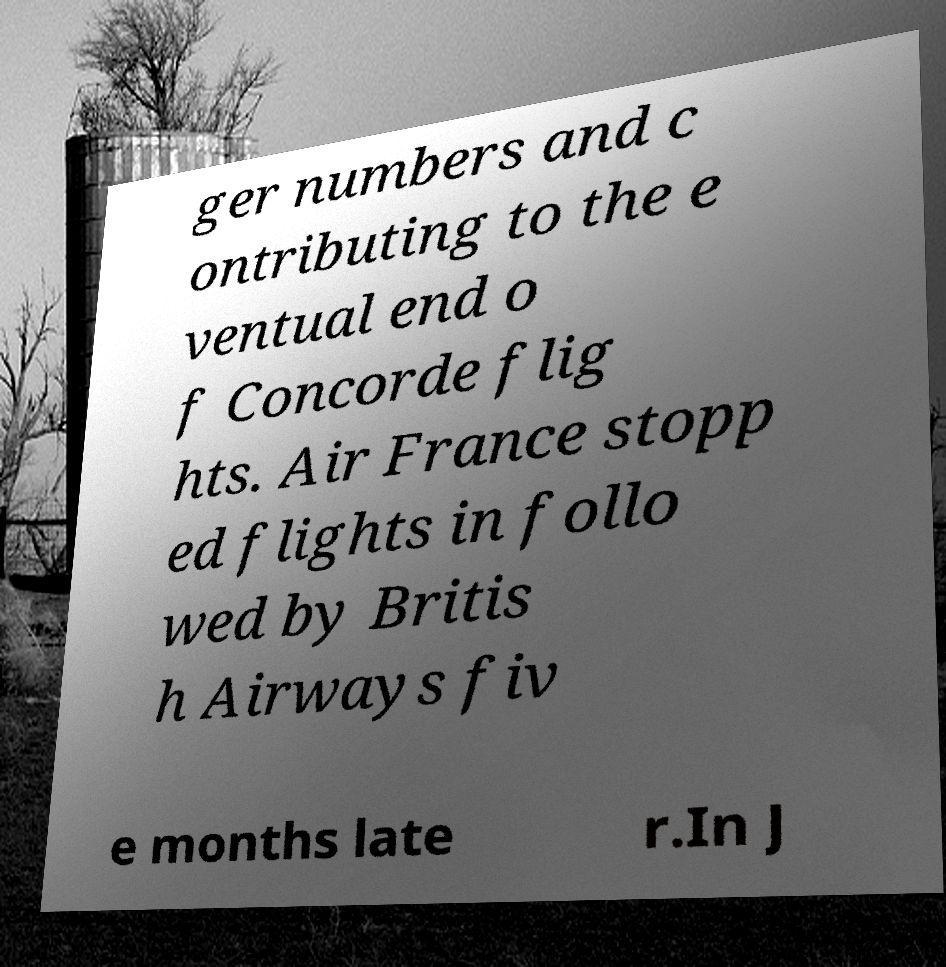Please read and relay the text visible in this image. What does it say? ger numbers and c ontributing to the e ventual end o f Concorde flig hts. Air France stopp ed flights in follo wed by Britis h Airways fiv e months late r.In J 